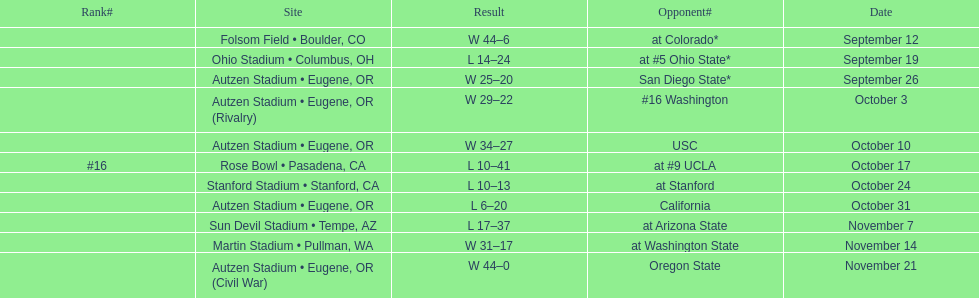Between september 26 and october 24, how many games were played in eugene, or? 3. 